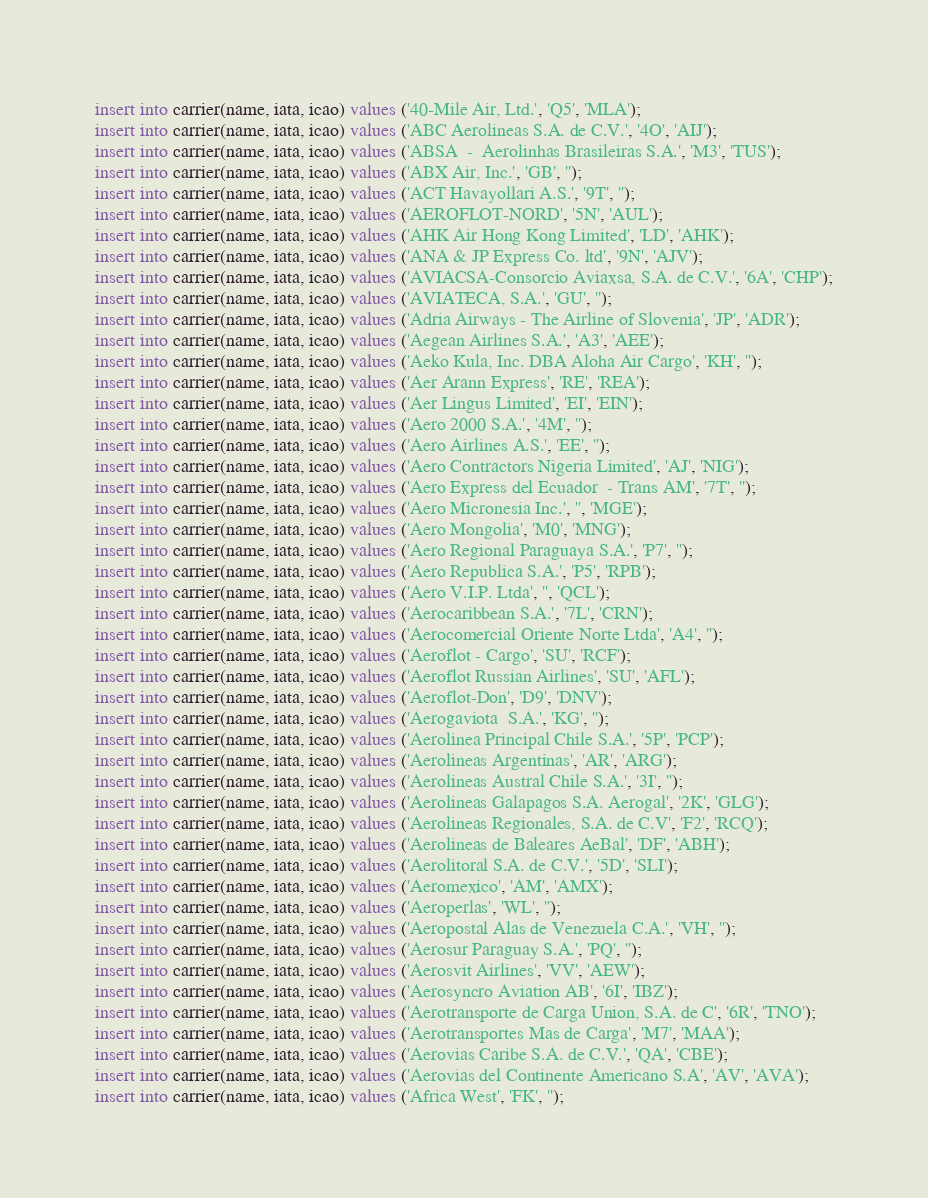<code> <loc_0><loc_0><loc_500><loc_500><_SQL_>insert into carrier(name, iata, icao) values ('40-Mile Air, Ltd.', 'Q5', 'MLA');
insert into carrier(name, iata, icao) values ('ABC Aerolineas S.A. de C.V.', '4O', 'AIJ');
insert into carrier(name, iata, icao) values ('ABSA  -  Aerolinhas Brasileiras S.A.', 'M3', 'TUS');
insert into carrier(name, iata, icao) values ('ABX Air, Inc.', 'GB', '');
insert into carrier(name, iata, icao) values ('ACT Havayollari A.S.', '9T', '');
insert into carrier(name, iata, icao) values ('AEROFLOT-NORD', '5N', 'AUL');
insert into carrier(name, iata, icao) values ('AHK Air Hong Kong Limited', 'LD', 'AHK');
insert into carrier(name, iata, icao) values ('ANA & JP Express Co. ltd', '9N', 'AJV');
insert into carrier(name, iata, icao) values ('AVIACSA-Consorcio Aviaxsa, S.A. de C.V.', '6A', 'CHP');
insert into carrier(name, iata, icao) values ('AVIATECA, S.A.', 'GU', '');
insert into carrier(name, iata, icao) values ('Adria Airways - The Airline of Slovenia', 'JP', 'ADR');
insert into carrier(name, iata, icao) values ('Aegean Airlines S.A.', 'A3', 'AEE');
insert into carrier(name, iata, icao) values ('Aeko Kula, Inc. DBA Aloha Air Cargo', 'KH', '');
insert into carrier(name, iata, icao) values ('Aer Arann Express', 'RE', 'REA');
insert into carrier(name, iata, icao) values ('Aer Lingus Limited', 'EI', 'EIN');
insert into carrier(name, iata, icao) values ('Aero 2000 S.A.', '4M', '');
insert into carrier(name, iata, icao) values ('Aero Airlines A.S.', 'EE', '');
insert into carrier(name, iata, icao) values ('Aero Contractors Nigeria Limited', 'AJ', 'NIG');
insert into carrier(name, iata, icao) values ('Aero Express del Ecuador  - Trans AM', '7T', '');
insert into carrier(name, iata, icao) values ('Aero Micronesia Inc.', '', 'MGE');
insert into carrier(name, iata, icao) values ('Aero Mongolia', 'M0', 'MNG');
insert into carrier(name, iata, icao) values ('Aero Regional Paraguaya S.A.', 'P7', '');
insert into carrier(name, iata, icao) values ('Aero Republica S.A.', 'P5', 'RPB');
insert into carrier(name, iata, icao) values ('Aero V.I.P. Ltda', '', 'QCL');
insert into carrier(name, iata, icao) values ('Aerocaribbean S.A.', '7L', 'CRN');
insert into carrier(name, iata, icao) values ('Aerocomercial Oriente Norte Ltda', 'A4', '');
insert into carrier(name, iata, icao) values ('Aeroflot - Cargo', 'SU', 'RCF');
insert into carrier(name, iata, icao) values ('Aeroflot Russian Airlines', 'SU', 'AFL');
insert into carrier(name, iata, icao) values ('Aeroflot-Don', 'D9', 'DNV');
insert into carrier(name, iata, icao) values ('Aerogaviota  S.A.', 'KG', '');
insert into carrier(name, iata, icao) values ('Aerolinea Principal Chile S.A.', '5P', 'PCP');
insert into carrier(name, iata, icao) values ('Aerolineas Argentinas', 'AR', 'ARG');
insert into carrier(name, iata, icao) values ('Aerolineas Austral Chile S.A.', '3I', '');
insert into carrier(name, iata, icao) values ('Aerolineas Galapagos S.A. Aerogal', '2K', 'GLG');
insert into carrier(name, iata, icao) values ('Aerolineas Regionales, S.A. de C.V', 'F2', 'RCQ');
insert into carrier(name, iata, icao) values ('Aerolineas de Baleares AeBal', 'DF', 'ABH');
insert into carrier(name, iata, icao) values ('Aerolitoral S.A. de C.V.', '5D', 'SLI');
insert into carrier(name, iata, icao) values ('Aeromexico', 'AM', 'AMX');
insert into carrier(name, iata, icao) values ('Aeroperlas', 'WL', '');
insert into carrier(name, iata, icao) values ('Aeropostal Alas de Venezuela C.A.', 'VH', '');
insert into carrier(name, iata, icao) values ('Aerosur Paraguay S.A.', 'PQ', '');
insert into carrier(name, iata, icao) values ('Aerosvit Airlines', 'VV', 'AEW');
insert into carrier(name, iata, icao) values ('Aerosyncro Aviation AB', '6I', 'IBZ');
insert into carrier(name, iata, icao) values ('Aerotransporte de Carga Union, S.A. de C', '6R', 'TNO');
insert into carrier(name, iata, icao) values ('Aerotransportes Mas de Carga', 'M7', 'MAA');
insert into carrier(name, iata, icao) values ('Aerovias Caribe S.A. de C.V.', 'QA', 'CBE');
insert into carrier(name, iata, icao) values ('Aerovias del Continente Americano S.A', 'AV', 'AVA');
insert into carrier(name, iata, icao) values ('Africa West', 'FK', '');</code> 